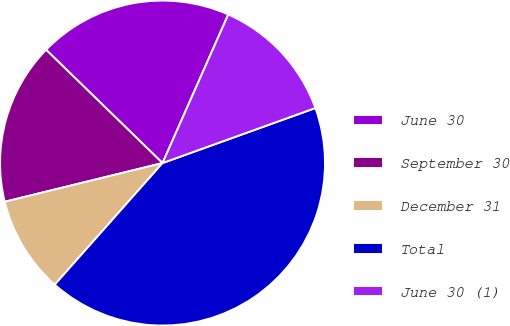Convert chart to OTSL. <chart><loc_0><loc_0><loc_500><loc_500><pie_chart><fcel>June 30<fcel>September 30<fcel>December 31<fcel>Total<fcel>June 30 (1)<nl><fcel>19.35%<fcel>16.11%<fcel>9.63%<fcel>42.04%<fcel>12.87%<nl></chart> 